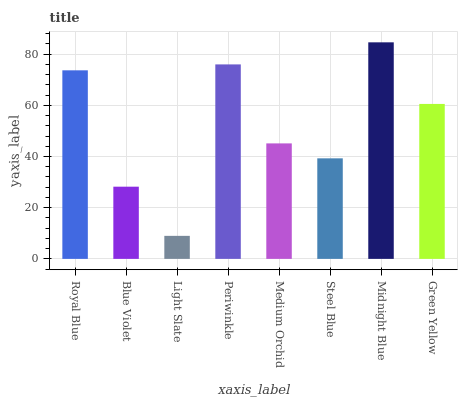Is Blue Violet the minimum?
Answer yes or no. No. Is Blue Violet the maximum?
Answer yes or no. No. Is Royal Blue greater than Blue Violet?
Answer yes or no. Yes. Is Blue Violet less than Royal Blue?
Answer yes or no. Yes. Is Blue Violet greater than Royal Blue?
Answer yes or no. No. Is Royal Blue less than Blue Violet?
Answer yes or no. No. Is Green Yellow the high median?
Answer yes or no. Yes. Is Medium Orchid the low median?
Answer yes or no. Yes. Is Midnight Blue the high median?
Answer yes or no. No. Is Midnight Blue the low median?
Answer yes or no. No. 